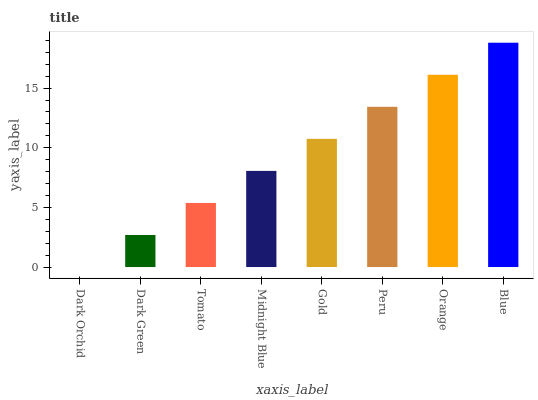Is Dark Green the minimum?
Answer yes or no. No. Is Dark Green the maximum?
Answer yes or no. No. Is Dark Green greater than Dark Orchid?
Answer yes or no. Yes. Is Dark Orchid less than Dark Green?
Answer yes or no. Yes. Is Dark Orchid greater than Dark Green?
Answer yes or no. No. Is Dark Green less than Dark Orchid?
Answer yes or no. No. Is Gold the high median?
Answer yes or no. Yes. Is Midnight Blue the low median?
Answer yes or no. Yes. Is Dark Green the high median?
Answer yes or no. No. Is Blue the low median?
Answer yes or no. No. 